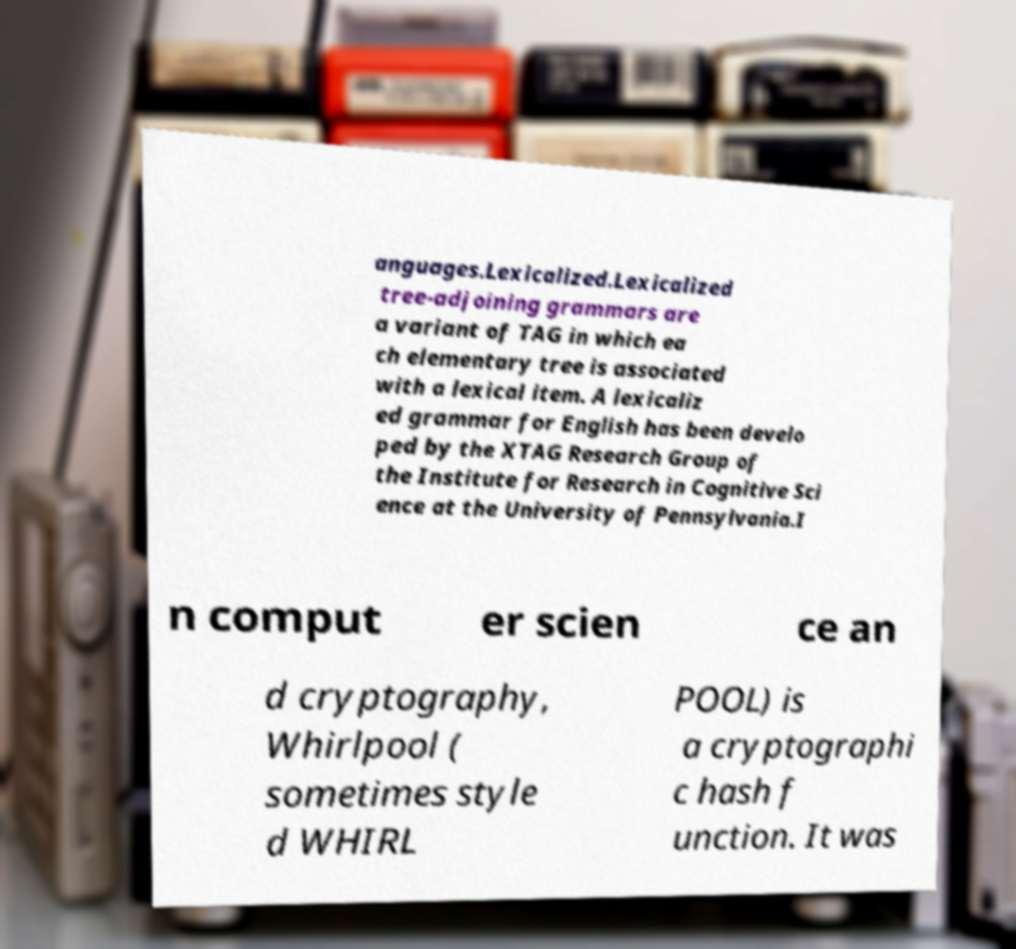What messages or text are displayed in this image? I need them in a readable, typed format. anguages.Lexicalized.Lexicalized tree-adjoining grammars are a variant of TAG in which ea ch elementary tree is associated with a lexical item. A lexicaliz ed grammar for English has been develo ped by the XTAG Research Group of the Institute for Research in Cognitive Sci ence at the University of Pennsylvania.I n comput er scien ce an d cryptography, Whirlpool ( sometimes style d WHIRL POOL) is a cryptographi c hash f unction. It was 